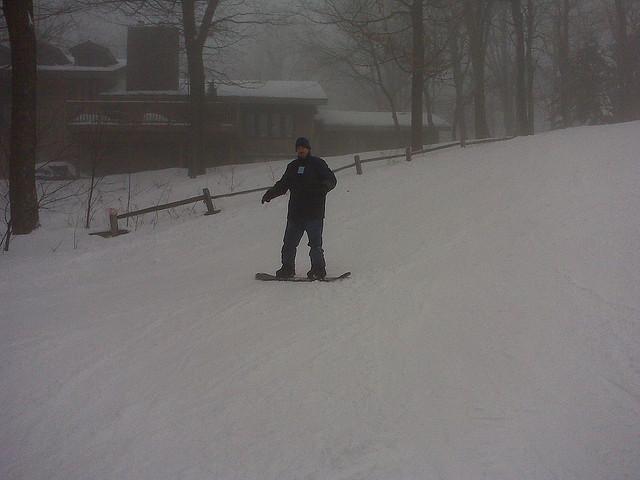How many levels are there to the building in the background?
Write a very short answer. 3. What is the cabin made of?
Write a very short answer. Wood. What color is the fence?
Write a very short answer. Brown. What is this person standing on?
Quick response, please. Snowboard. What is this man standing on?
Give a very brief answer. Snowboard. What season is this?
Concise answer only. Winter. Is there snow on the ground under the stop sign?
Give a very brief answer. Yes. What color jacket is the person wearing?
Quick response, please. Black. 